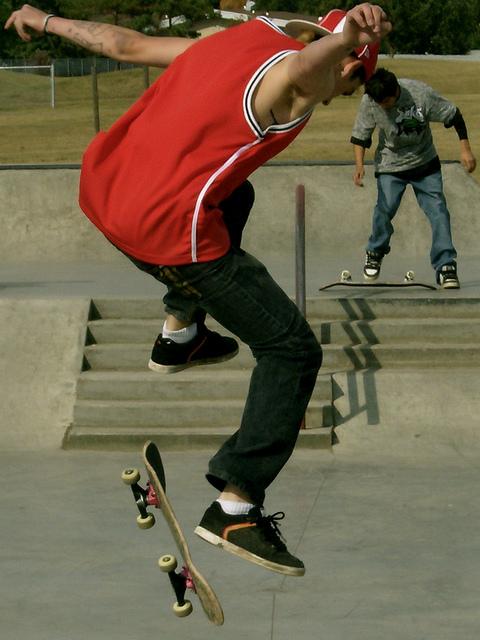How many wheels are on this skateboard?
Answer briefly. 4. What color is the man's pants?
Give a very brief answer. Black. What is the man trying to hit?
Short answer required. Skateboard. Why are the skateboard and the rider airborne?
Concise answer only. Jumping. What color is this person's shirt?
Concise answer only. Red. What color scheme is the photo taken in?
Be succinct. Color. What color is his shoes?
Short answer required. Black. How many skateboards in the photo?
Give a very brief answer. 2. 